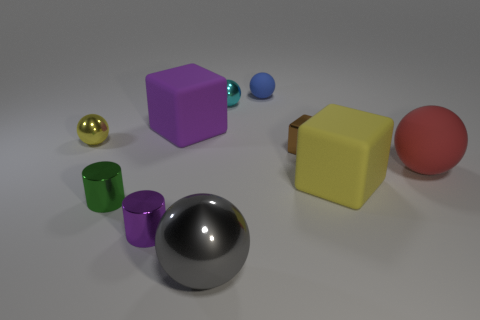What number of balls are either big yellow things or gray metal objects?
Offer a very short reply. 1. What color is the big shiny object?
Offer a very short reply. Gray. How many objects are brown blocks or big gray objects?
Make the answer very short. 2. There is a brown thing that is the same size as the purple shiny cylinder; what is it made of?
Offer a very short reply. Metal. There is a metal object that is in front of the small purple metallic cylinder; what is its size?
Keep it short and to the point. Large. What material is the red sphere?
Provide a short and direct response. Rubber. How many things are either rubber blocks on the right side of the small blue matte sphere or small things in front of the red ball?
Give a very brief answer. 3. How many other things are there of the same color as the tiny block?
Provide a short and direct response. 0. Is the shape of the brown thing the same as the rubber thing that is in front of the large red ball?
Offer a terse response. Yes. Is the number of brown blocks behind the brown block less than the number of small blue rubber balls that are on the right side of the blue sphere?
Offer a very short reply. No. 